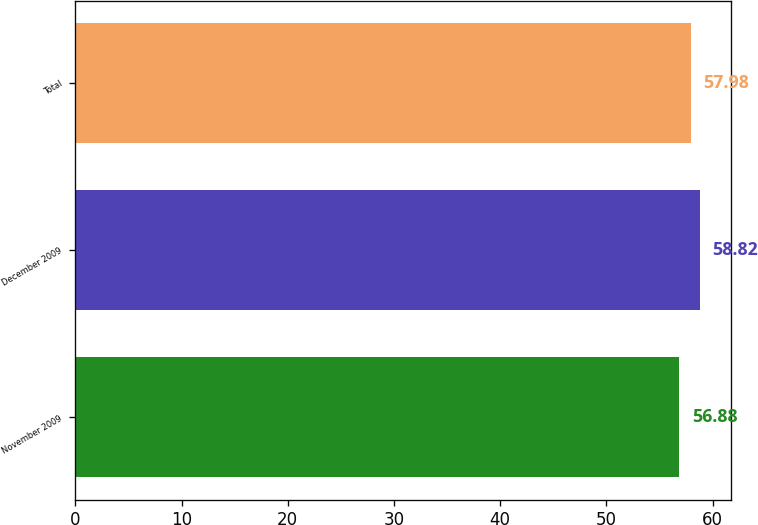Convert chart. <chart><loc_0><loc_0><loc_500><loc_500><bar_chart><fcel>November 2009<fcel>December 2009<fcel>Total<nl><fcel>56.88<fcel>58.82<fcel>57.98<nl></chart> 